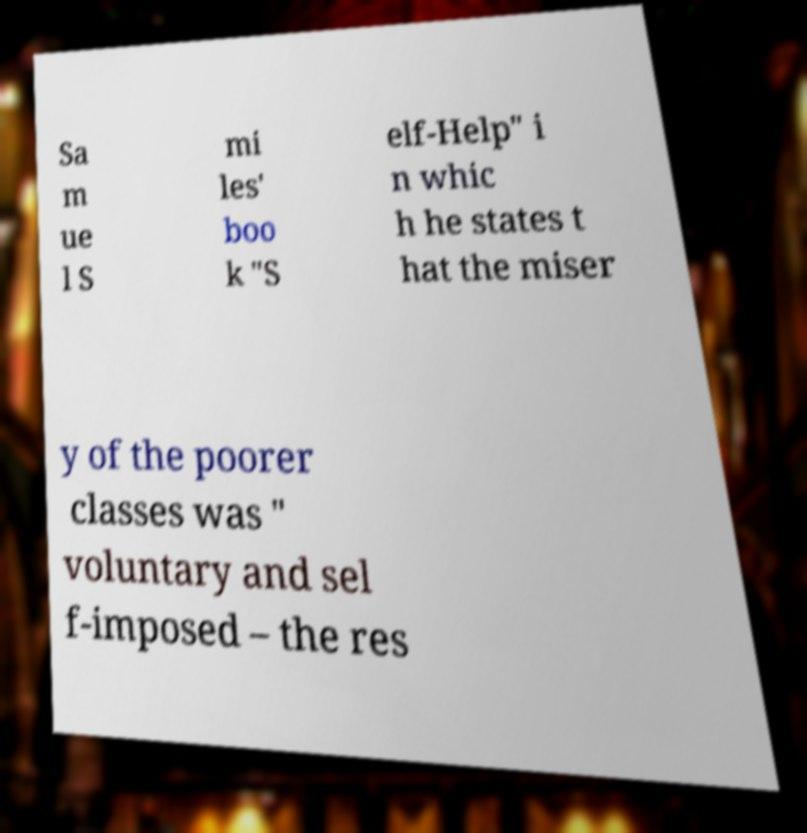What messages or text are displayed in this image? I need them in a readable, typed format. Sa m ue l S mi les' boo k "S elf-Help" i n whic h he states t hat the miser y of the poorer classes was " voluntary and sel f-imposed – the res 